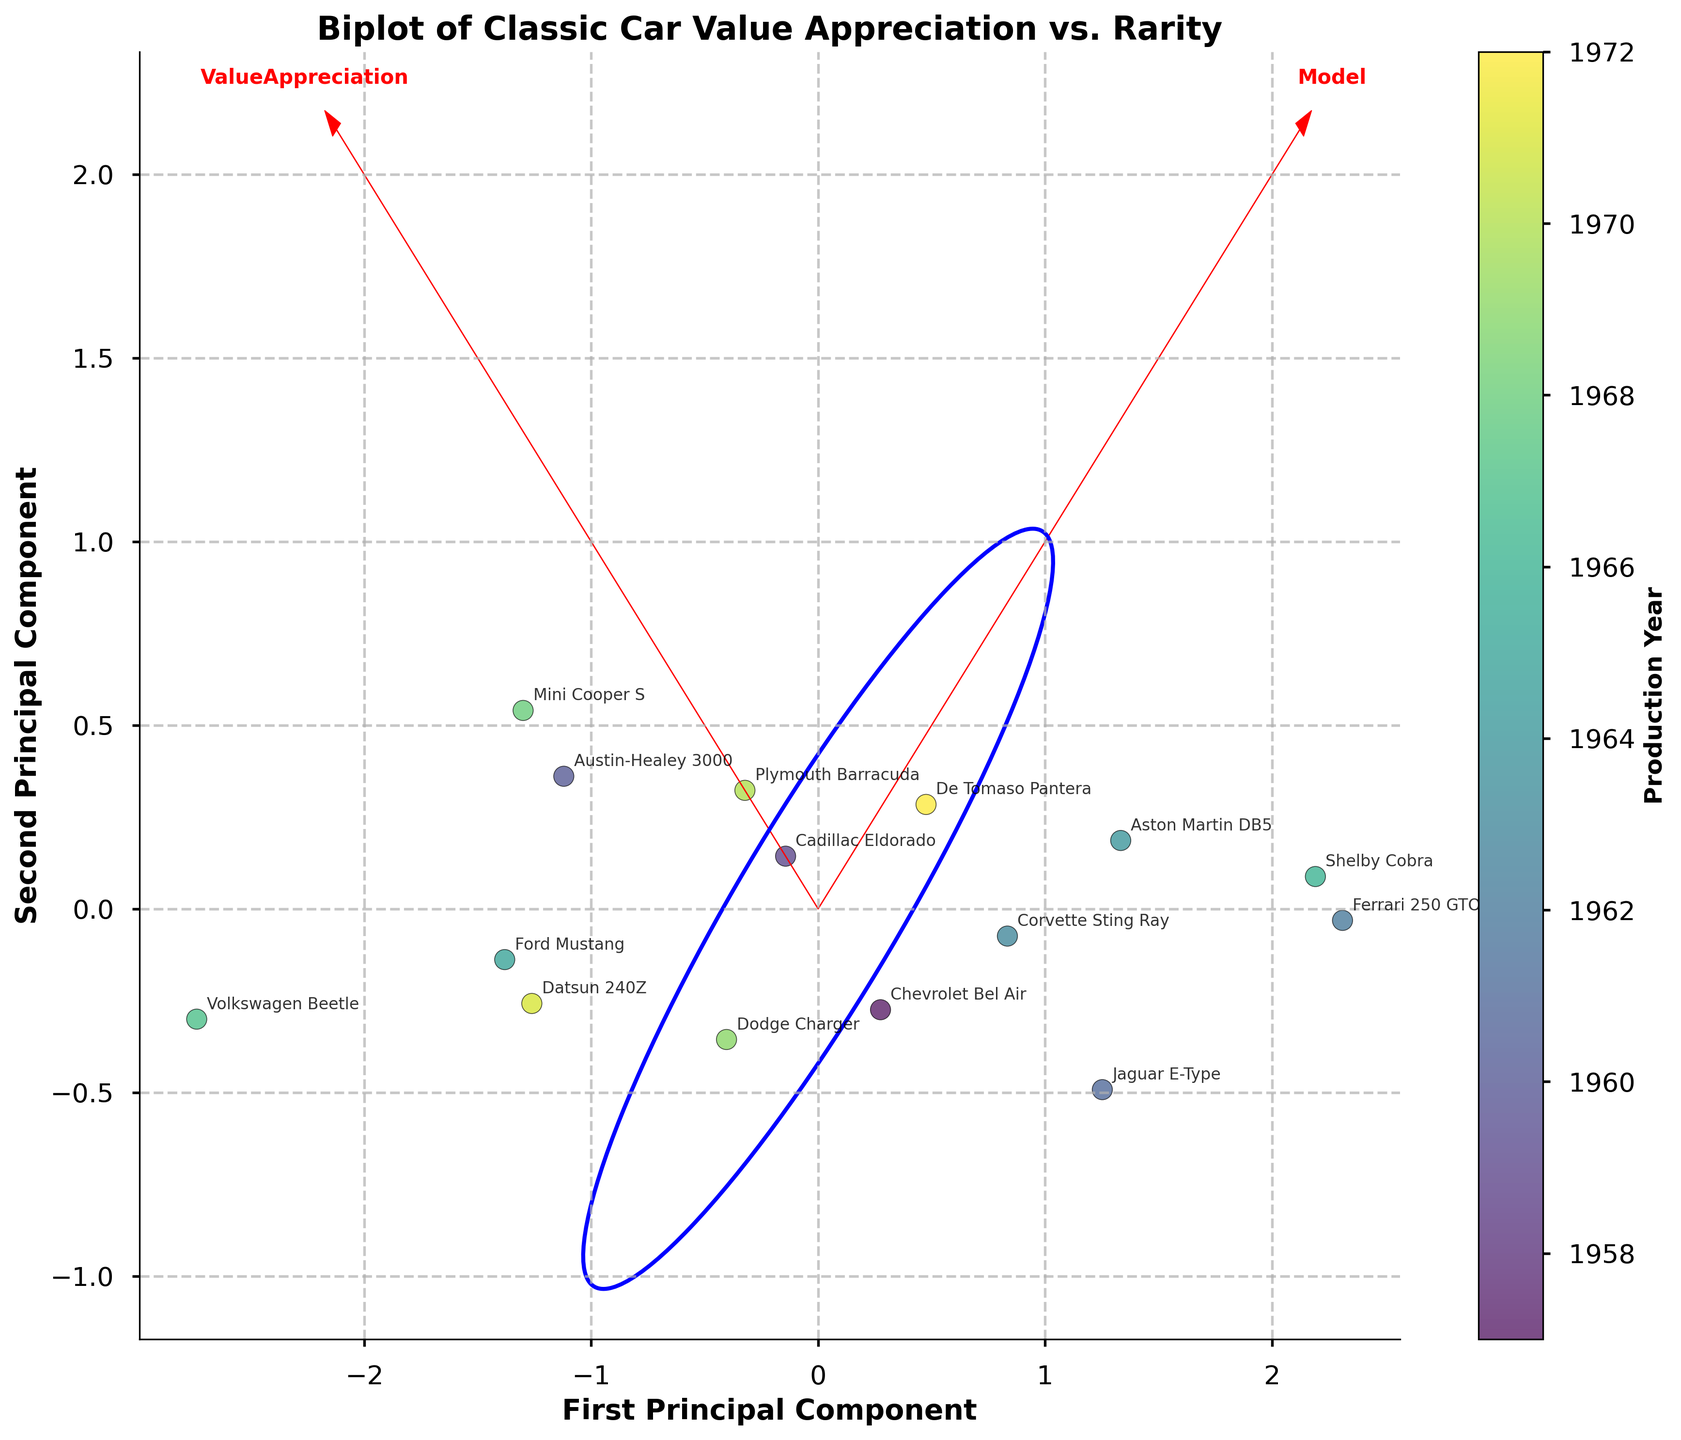What's the title of the plot? The title is located at the top of the figure, typically in a larger or bolder font to stand out. It provides an overarching description of what the plot represents.
Answer: Biplot of Classic Car Value Appreciation vs. Rarity How many cars are being analyzed in this biplot? Each dot in the scatter plot represents one car model. By counting the dots, we can determine the number of car models analyzed.
Answer: 15 What are the axis labels in the biplot? Axis labels are typically found along the x and y axes. They provide information on what each axis represents.
Answer: First Principal Component (x-axis) and Second Principal Component (y-axis) Which car model has the highest value appreciation? By analyzing the annotations close to the edges of the plot, one can identify the car model with the highest value appreciation. Look for labels near the higher end of the principal component scores.
Answer: Ferrari 250 GTO Which car model is associated with the year 1965? By matching the color gradient of the year 1965 on the color bar with the corresponding dot on the plot, we can determine which model it represents. Additionally, each point is labeled with a car model.
Answer: Ford Mustang Are there any car models that show high value appreciation but are less rare? To answer this, look for points on the right side of the feature vector for "Value Appreciation" but closer to the center or lower side for "Rarity." The points should be closer to models but not the furthest ones from the origin of the rarity axis.
Answer: Chevrolet Bel Air Which feature (Value Appreciation or Rarity) has a larger influence on the first principal component? The length and direction of the arrows from the origin toward each feature vector tell us about their influence on the principal components. The longer the arrow, the larger the influence.
Answer: Value Appreciation Between 1957 and 1965, how many car models are present? By analyzing the color bar and identifying the range that corresponds to the years 1957 to 1965, we can count the number of dots within this range. This includes identifying the respective car models as well.
Answer: 4 Which two car models are closest to each other in the plot? Look for pairs of dots that are nearest to each other based on their positions. Identification can be done based on annotations or the proximity of dots on the plot.
Answer: Datsun 240Z and Mini Cooper S 